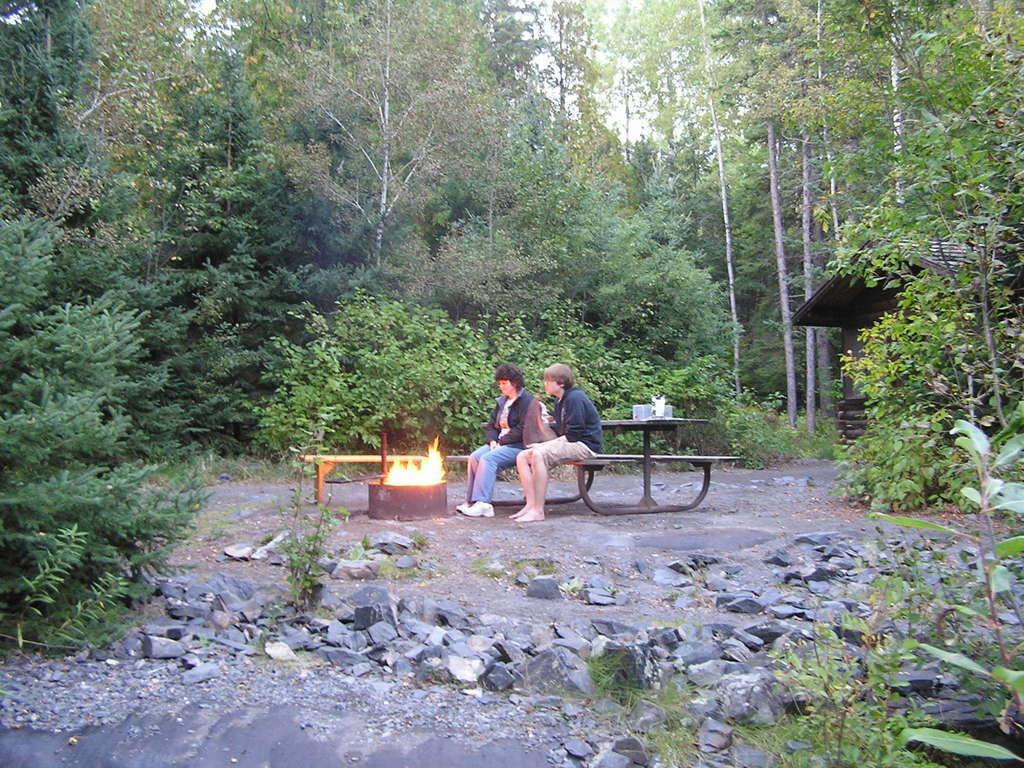Can you describe this image briefly? In this image we can see many trees and plants. There are many stones in the image. There are two persons sitting on the bench. There are few objects placed on the table. There is a sky in the image. There is a house in the image. 